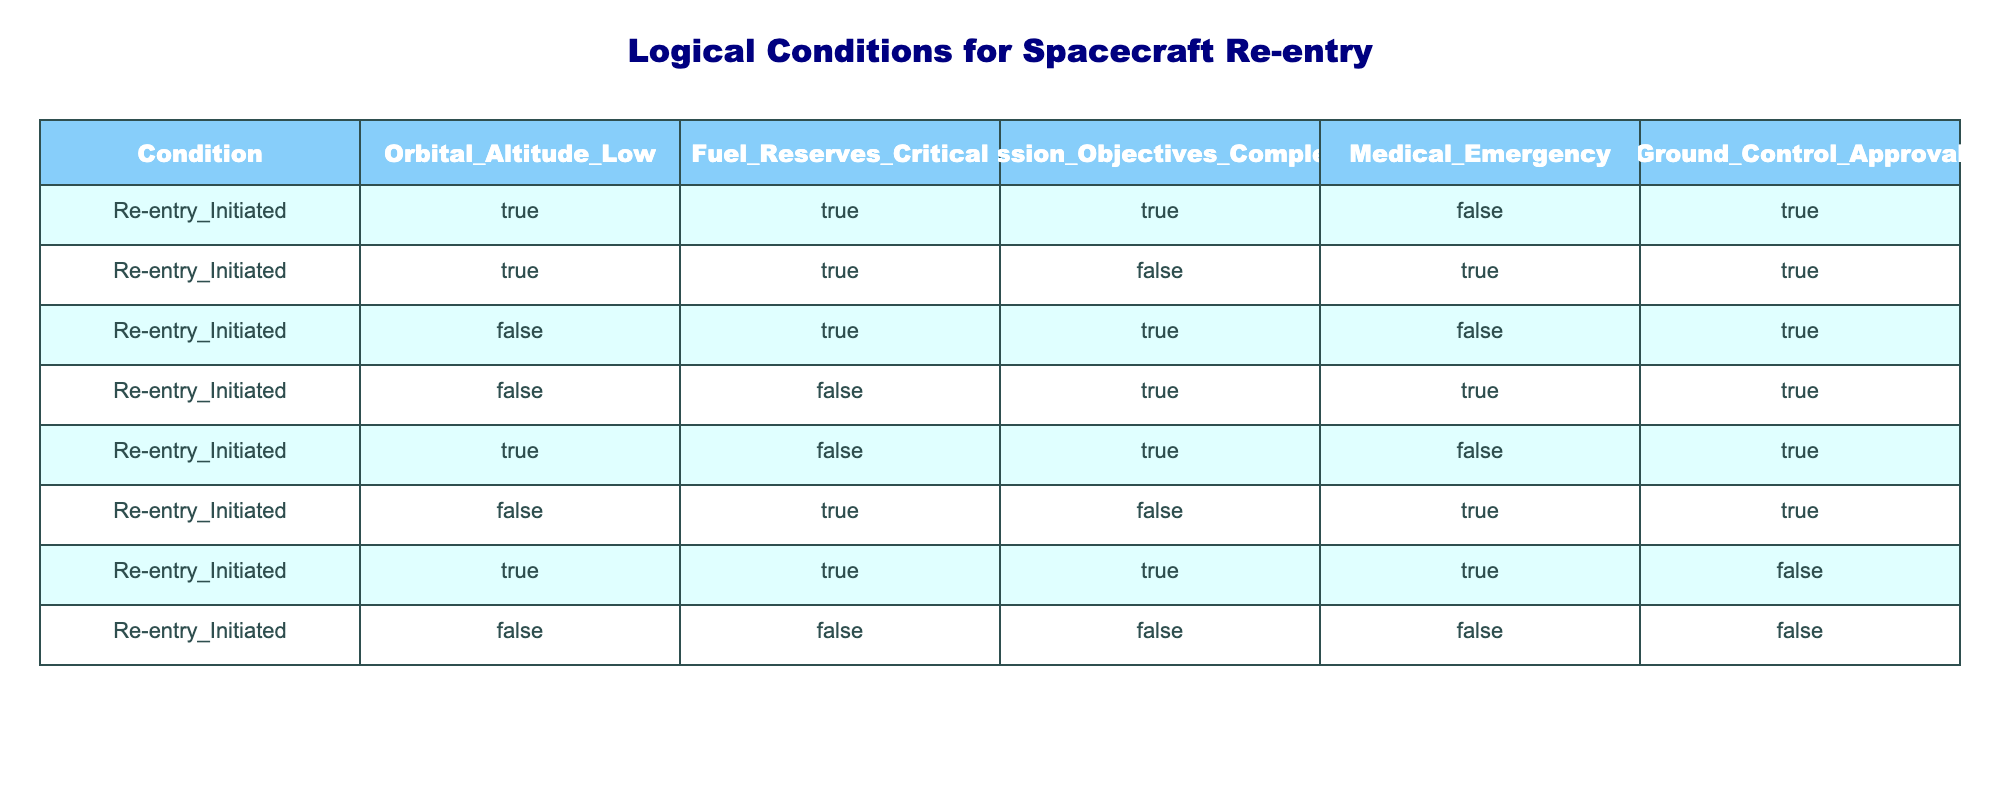What are the conditions that allow for re-entry to be initiated with Ground Control Approval? The table shows that re-entry can be initiated when Ground Control Approval is true under conditions where Orbital Altitude is either true or false, Fuel Reserves can be true or false as well, but Medical Emergency must be false.
Answer: Orbital Altitude: TRUE, Fuel Reserves: TRUE; Orbital Altitude: FALSE, Fuel Reserves: TRUE How many total conditions lead to re-entry initiation? Counting the rows in the table, there are 8 different instances indicating when re-entry is initiated.
Answer: 8 Is a Medical Emergency ever a condition for re-entry to be initiated? Observing the table, there are no circumstances where Medical Emergency is true while initiating re-entry, only false conditions are present.
Answer: No What percentage of conditions show that Fuel Reserves must be critical for re-entry initiation? In the table, there are 3 instances where Fuel Reserves are critical (true) out of a total of 8 rows. To find the percentage, we divide 3 by 8 and multiply by 100, giving us 37.5%.
Answer: 37.5% Can re-entry be initiated without Ground Control Approval? By examining the table, we find that re-entry can only be initiated without Ground Control Approval if Medical Emergency is true and Fuel Reserves are critical, but these conditions do not intersect with instances of true Ground Control Approval.
Answer: No If Orbital Altitude is false, what are the possible conditions for re-entry initiation? Analyzing the rows, when Orbital Altitude is false, re-entry could be initiated if Fuel Reserves are true (with or without Medical Emergency leading to Ground Control Approval) or if both Fuel Reserves and Mission Objectives are false (only with a Medical Emergency).
Answer: Fuel Reserves: TRUE or FALSE; Medical Emergency: TRUE How many times can re-entry be initiated with Mission Objectives complete and Fuel Reserves critical? Reviewing the table, there are 3 instances where both Mission Objectives are complete and Fuel Reserves are critical (5 times, counting different Logical Conditions).
Answer: 3 Are there instances where both a Medical Emergency and Mission Objectives Complete return true during re-entry initiation? Checking the table, we see that there are two scenarios where Medical Emergency is true, but Mission Objectives are not complete in those cases when re-entry is initiated. Hence, both cannot be true simultaneously.
Answer: No 